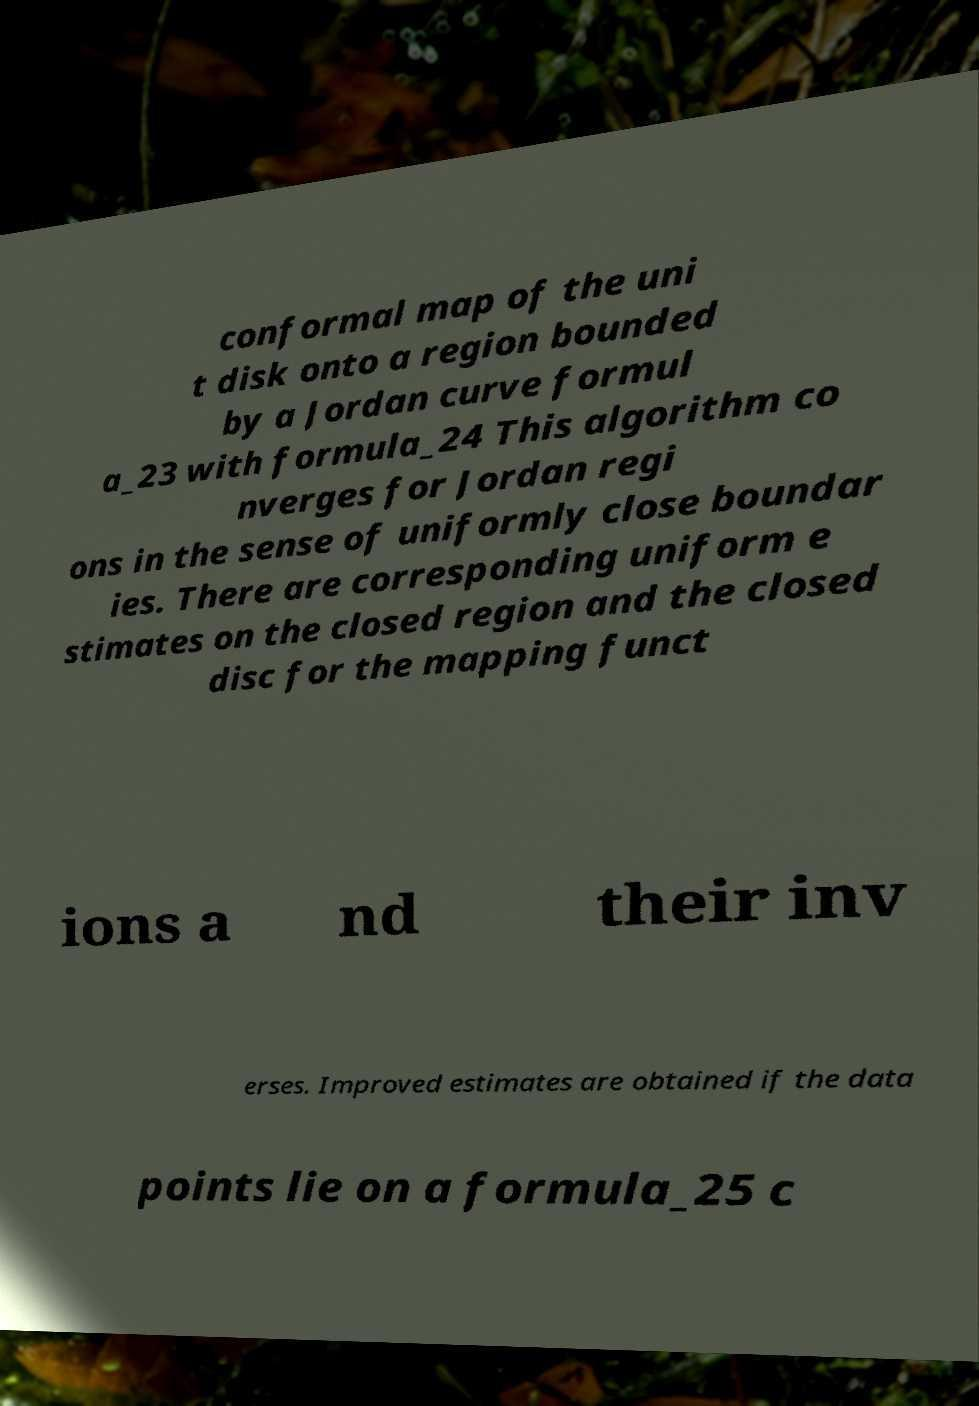Can you accurately transcribe the text from the provided image for me? conformal map of the uni t disk onto a region bounded by a Jordan curve formul a_23 with formula_24 This algorithm co nverges for Jordan regi ons in the sense of uniformly close boundar ies. There are corresponding uniform e stimates on the closed region and the closed disc for the mapping funct ions a nd their inv erses. Improved estimates are obtained if the data points lie on a formula_25 c 